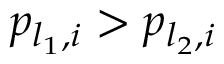Convert formula to latex. <formula><loc_0><loc_0><loc_500><loc_500>p _ { l _ { 1 } , i } > p _ { l _ { 2 } , i }</formula> 